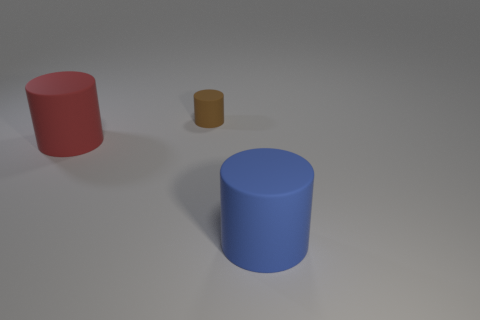What is the shape of the big blue object?
Keep it short and to the point. Cylinder. What number of large blue cylinders have the same material as the small thing?
Ensure brevity in your answer.  1. There is a small object that is the same material as the blue cylinder; what color is it?
Offer a very short reply. Brown. Do the rubber cylinder in front of the red cylinder and the red cylinder have the same size?
Your answer should be very brief. Yes. What color is the other small thing that is the same shape as the blue object?
Your response must be concise. Brown. There is a large rubber thing in front of the large rubber object behind the big matte thing right of the tiny brown matte cylinder; what is its shape?
Give a very brief answer. Cylinder. Does the blue object have the same shape as the brown matte object?
Give a very brief answer. Yes. What shape is the large thing on the left side of the thing that is in front of the red rubber object?
Provide a short and direct response. Cylinder. Are any big red cylinders visible?
Your response must be concise. Yes. What number of rubber objects are in front of the big cylinder that is behind the rubber thing to the right of the small cylinder?
Offer a very short reply. 1. 